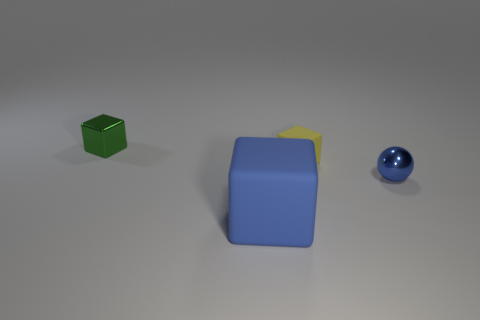Subtract all blue blocks. How many blocks are left? 2 Add 4 big blue things. How many objects exist? 8 Subtract all spheres. How many objects are left? 3 Add 2 tiny shiny things. How many tiny shiny things are left? 4 Add 1 gray cubes. How many gray cubes exist? 1 Subtract 0 red cylinders. How many objects are left? 4 Subtract all small objects. Subtract all large blue blocks. How many objects are left? 0 